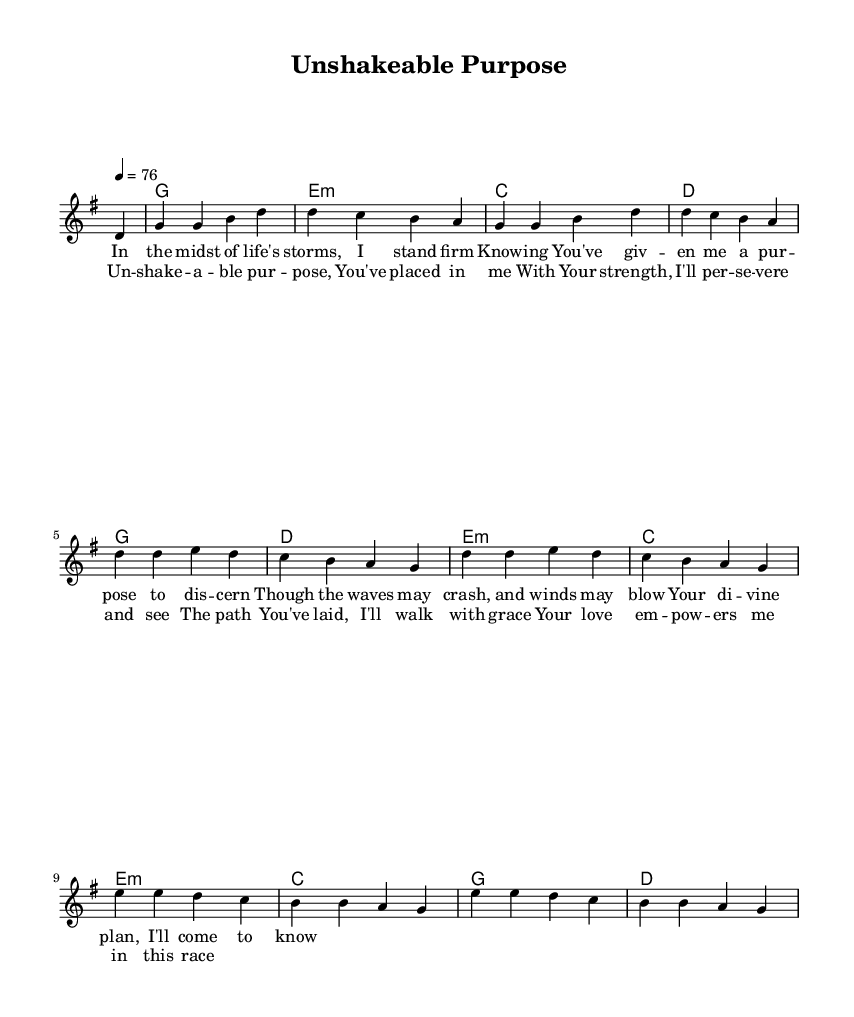What is the key signature of this music? The key signature is indicated at the beginning of the score, and it shows one sharp, which is characteristic of G major.
Answer: G major What is the time signature of this music? The time signature is displayed at the start of the sheet music, indicating a regular counting of four beats per measure.
Answer: 4/4 What is the tempo marking for this piece? The tempo marking is specified above the staff and indicates the speed at which the music should be played, given as a quarter note equals seventy-six beats per minute.
Answer: 76 How many measures are in the first verse? By counting the number of distinct segments separated by vertical bars in the verse lyrics, there are a total of four measures where text is set to music.
Answer: 4 What chord is played in measure 2? The chord changes are noted at the beginning of each measure, and in the second measure, it is visibly indicated as E minor.
Answer: E minor What theme do the lyrics emphasize? By analyzing the lyrical content, it can be deduced that the lyrics focus on steadfastness and divine purpose, highlighting perseverance through life's challenges.
Answer: Perseverance What emotion is conveyed in the chorus? The language used in the chorus suggests empowerment and determination, highlighting a feeling of strength and commitment to a path of grace.
Answer: Empowerment 